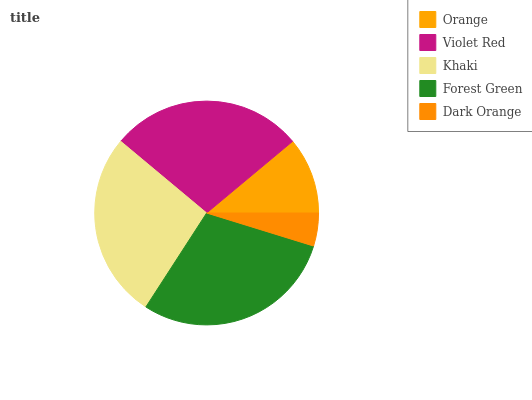Is Dark Orange the minimum?
Answer yes or no. Yes. Is Forest Green the maximum?
Answer yes or no. Yes. Is Violet Red the minimum?
Answer yes or no. No. Is Violet Red the maximum?
Answer yes or no. No. Is Violet Red greater than Orange?
Answer yes or no. Yes. Is Orange less than Violet Red?
Answer yes or no. Yes. Is Orange greater than Violet Red?
Answer yes or no. No. Is Violet Red less than Orange?
Answer yes or no. No. Is Khaki the high median?
Answer yes or no. Yes. Is Khaki the low median?
Answer yes or no. Yes. Is Orange the high median?
Answer yes or no. No. Is Violet Red the low median?
Answer yes or no. No. 